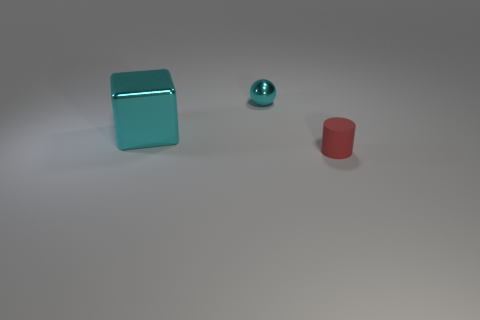There is a tiny red rubber thing; is it the same shape as the small thing on the left side of the small red cylinder?
Provide a short and direct response. No. How many other objects are the same material as the small cylinder?
Keep it short and to the point. 0. What material is the small cyan object?
Provide a short and direct response. Metal. There is a tiny object that is on the left side of the small cylinder; is it the same color as the thing that is in front of the cube?
Your response must be concise. No. Is the number of spheres behind the red rubber thing greater than the number of metallic spheres?
Offer a terse response. No. How many other things are there of the same color as the rubber object?
Your answer should be very brief. 0. Is the size of the object that is on the left side of the cyan sphere the same as the small cylinder?
Your answer should be very brief. No. Are there any red cylinders of the same size as the metal cube?
Your answer should be very brief. No. What color is the thing behind the cyan shiny block?
Provide a short and direct response. Cyan. What is the shape of the thing that is in front of the tiny cyan sphere and right of the large block?
Provide a short and direct response. Cylinder. 